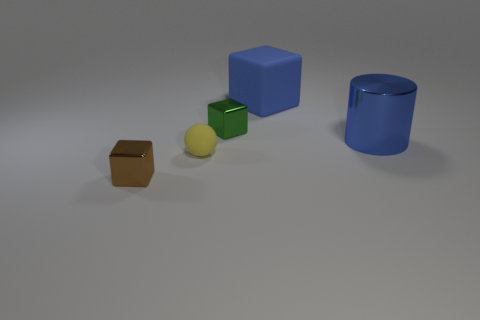Subtract all tiny brown blocks. How many blocks are left? 2 Add 3 cylinders. How many objects exist? 8 Subtract all cubes. How many objects are left? 2 Add 1 blue shiny things. How many blue shiny things exist? 2 Subtract 1 green cubes. How many objects are left? 4 Subtract all tiny yellow rubber cylinders. Subtract all large blue rubber things. How many objects are left? 4 Add 5 green shiny blocks. How many green shiny blocks are left? 6 